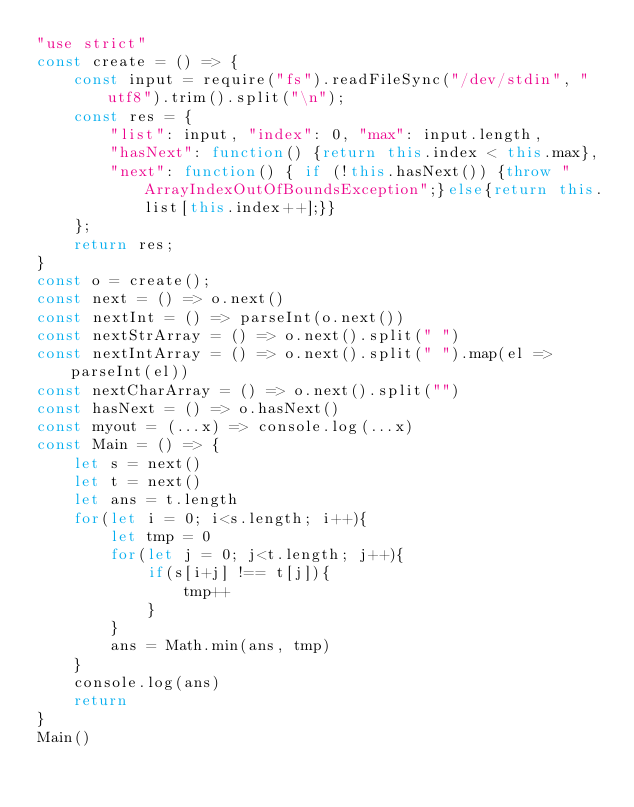<code> <loc_0><loc_0><loc_500><loc_500><_JavaScript_>"use strict"
const create = () => {
    const input = require("fs").readFileSync("/dev/stdin", "utf8").trim().split("\n");
    const res = {
        "list": input, "index": 0, "max": input.length,
        "hasNext": function() {return this.index < this.max},
        "next": function() { if (!this.hasNext()) {throw "ArrayIndexOutOfBoundsException";}else{return this.list[this.index++];}}
    };
    return res;
}
const o = create();
const next = () => o.next()
const nextInt = () => parseInt(o.next())
const nextStrArray = () => o.next().split(" ")
const nextIntArray = () => o.next().split(" ").map(el => parseInt(el))
const nextCharArray = () => o.next().split("")
const hasNext = () => o.hasNext()
const myout = (...x) => console.log(...x)
const Main = () => {
    let s = next()
    let t = next()
    let ans = t.length
    for(let i = 0; i<s.length; i++){
        let tmp = 0 
        for(let j = 0; j<t.length; j++){
            if(s[i+j] !== t[j]){
                tmp++
            }
        }
        ans = Math.min(ans, tmp)
    }
    console.log(ans)
    return
}
Main()
</code> 